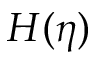Convert formula to latex. <formula><loc_0><loc_0><loc_500><loc_500>H ( \eta )</formula> 